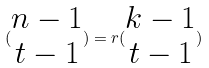Convert formula to latex. <formula><loc_0><loc_0><loc_500><loc_500>( \begin{matrix} n - 1 \\ t - 1 \end{matrix} ) = r ( \begin{matrix} k - 1 \\ t - 1 \end{matrix} )</formula> 